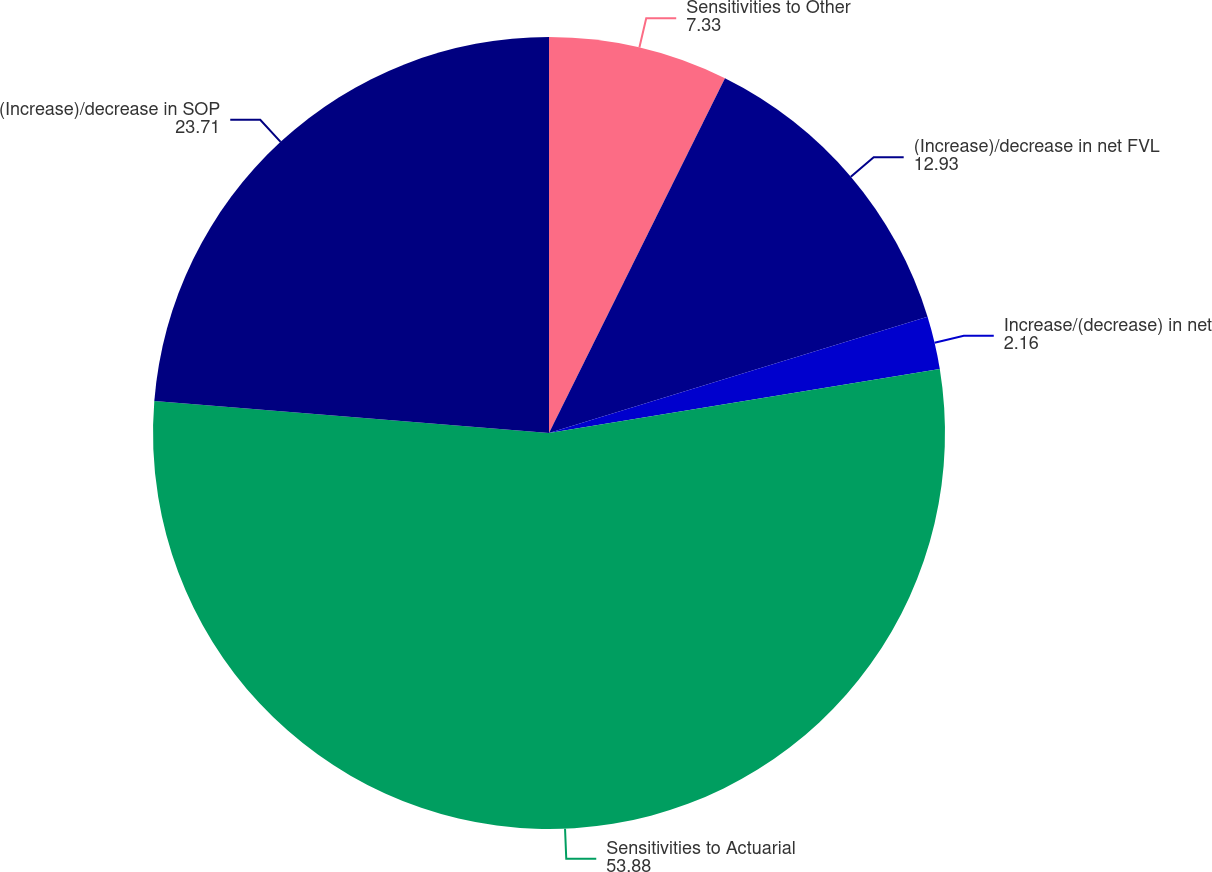Convert chart. <chart><loc_0><loc_0><loc_500><loc_500><pie_chart><fcel>Sensitivities to Other<fcel>(Increase)/decrease in net FVL<fcel>Increase/(decrease) in net<fcel>Sensitivities to Actuarial<fcel>(Increase)/decrease in SOP<nl><fcel>7.33%<fcel>12.93%<fcel>2.16%<fcel>53.88%<fcel>23.71%<nl></chart> 